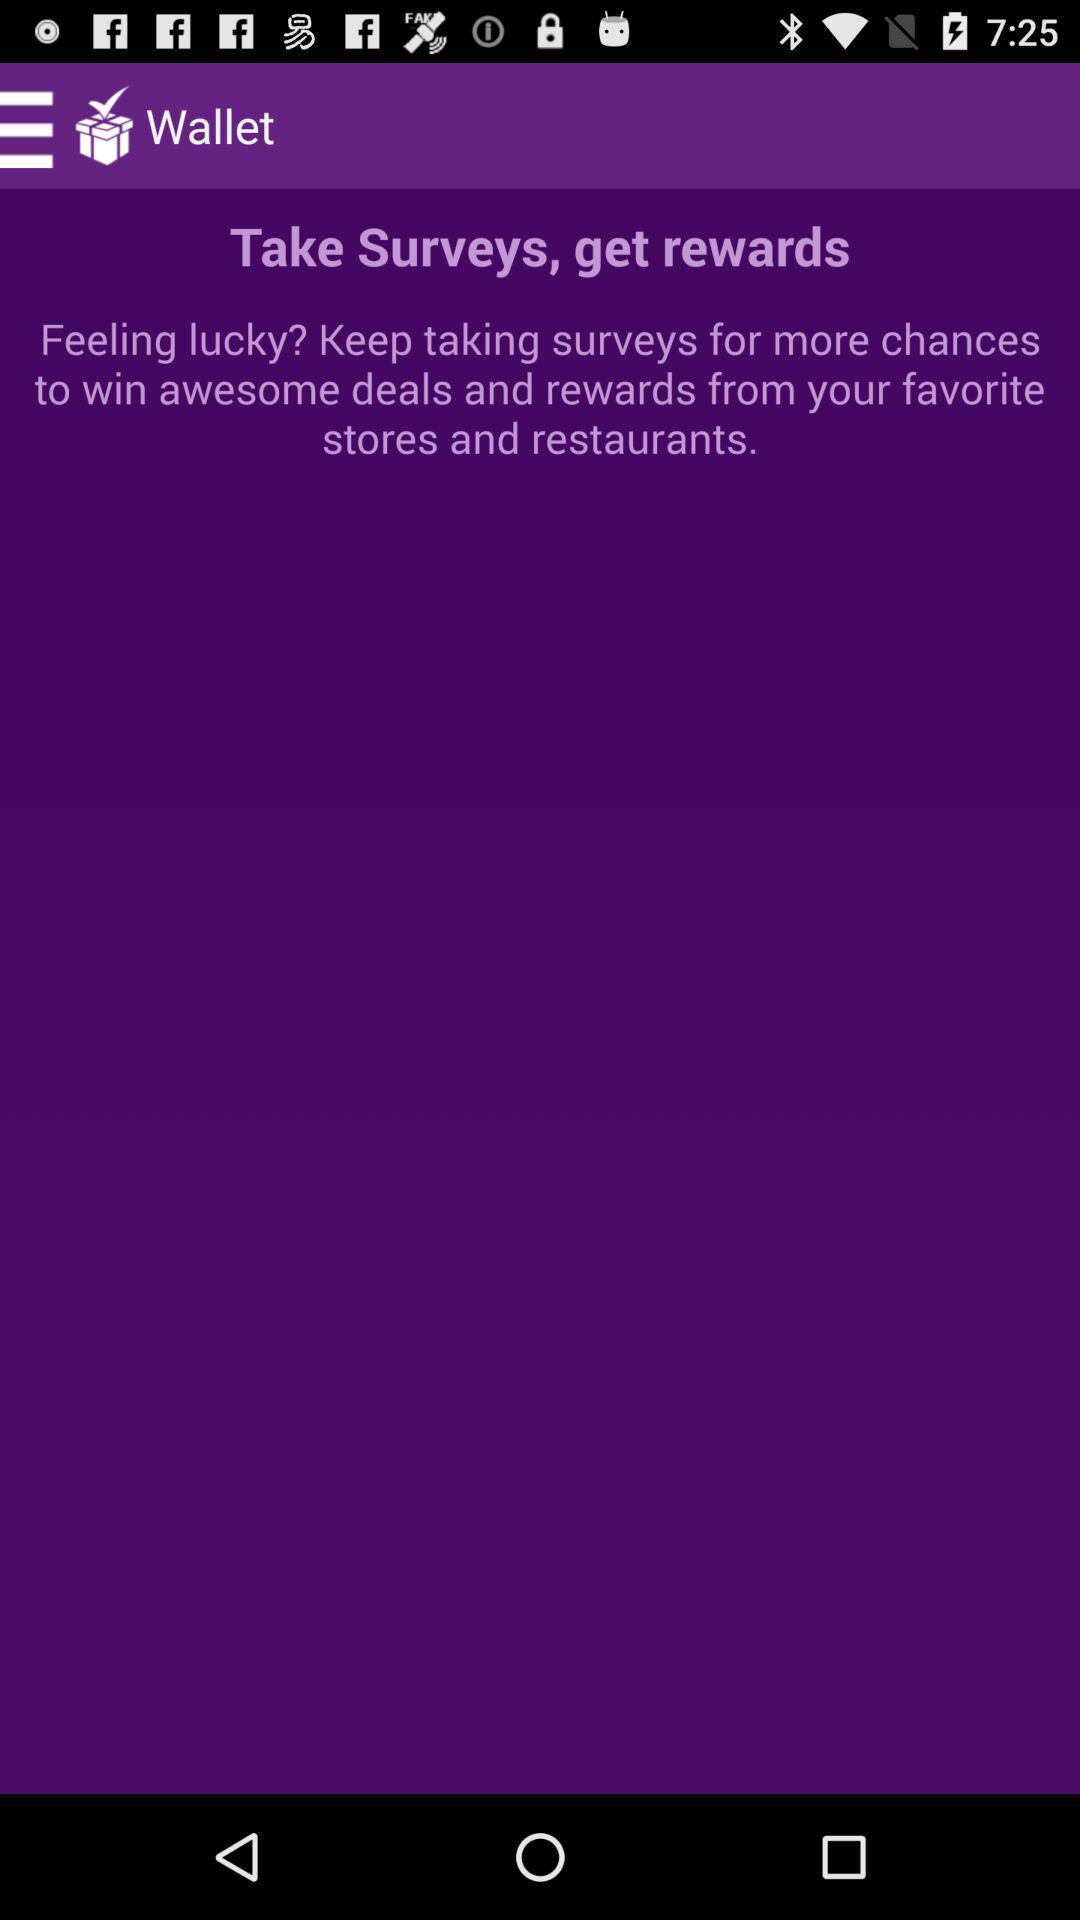What is the name of the application? The application is "Wallet". 